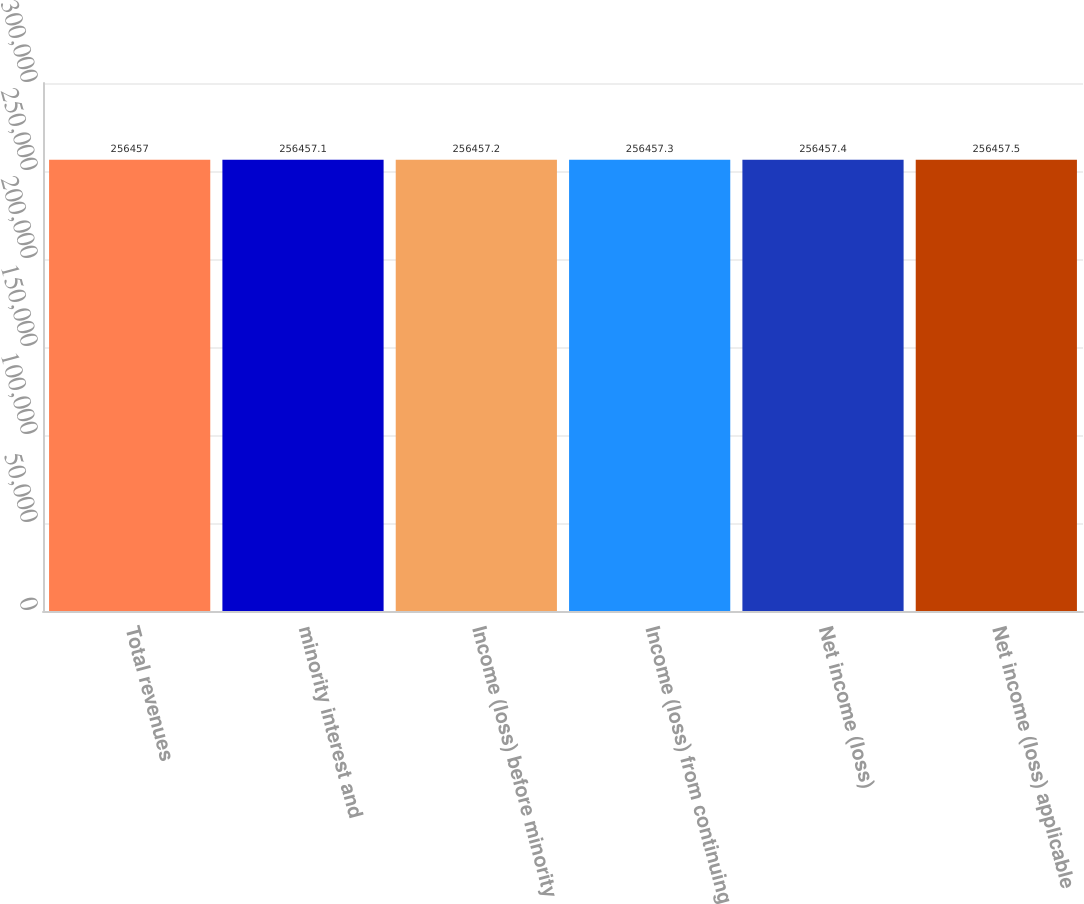Convert chart. <chart><loc_0><loc_0><loc_500><loc_500><bar_chart><fcel>Total revenues<fcel>minority interest and<fcel>Income (loss) before minority<fcel>Income (loss) from continuing<fcel>Net income (loss)<fcel>Net income (loss) applicable<nl><fcel>256457<fcel>256457<fcel>256457<fcel>256457<fcel>256457<fcel>256458<nl></chart> 